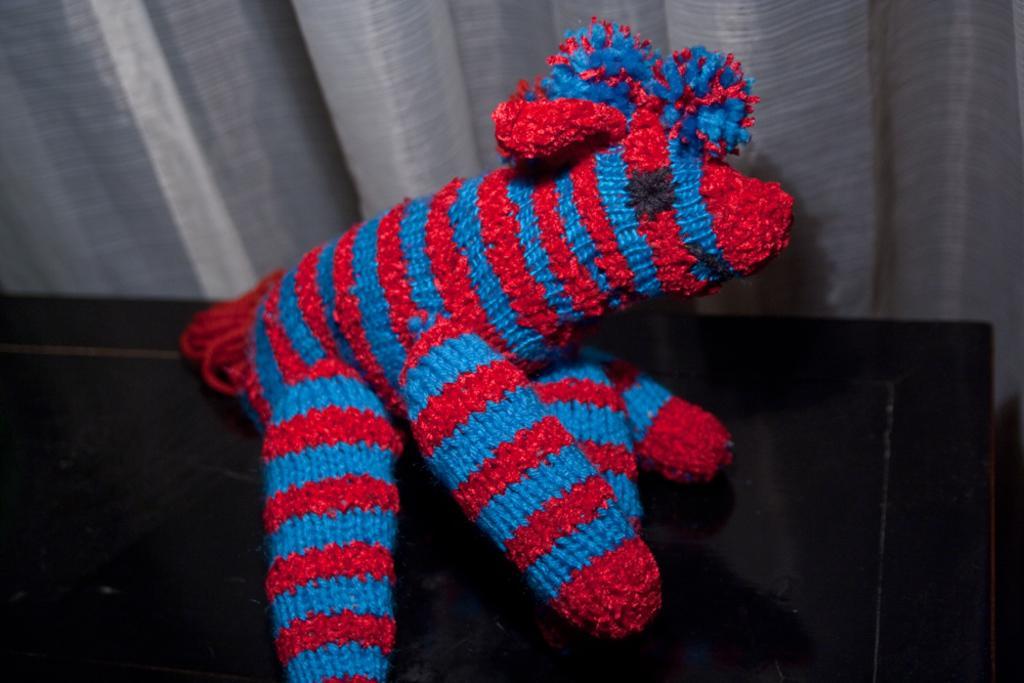How would you summarize this image in a sentence or two? In this image I can see an object which is blue, red and black in color on the black colored object. In the background I can see ash colored curtain. 